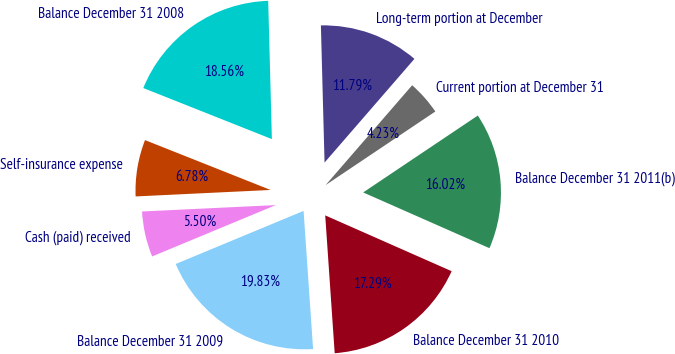Convert chart. <chart><loc_0><loc_0><loc_500><loc_500><pie_chart><fcel>Balance December 31 2008<fcel>Self-insurance expense<fcel>Cash (paid) received<fcel>Balance December 31 2009<fcel>Balance December 31 2010<fcel>Balance December 31 2011(b)<fcel>Current portion at December 31<fcel>Long-term portion at December<nl><fcel>18.56%<fcel>6.78%<fcel>5.5%<fcel>19.83%<fcel>17.29%<fcel>16.02%<fcel>4.23%<fcel>11.79%<nl></chart> 